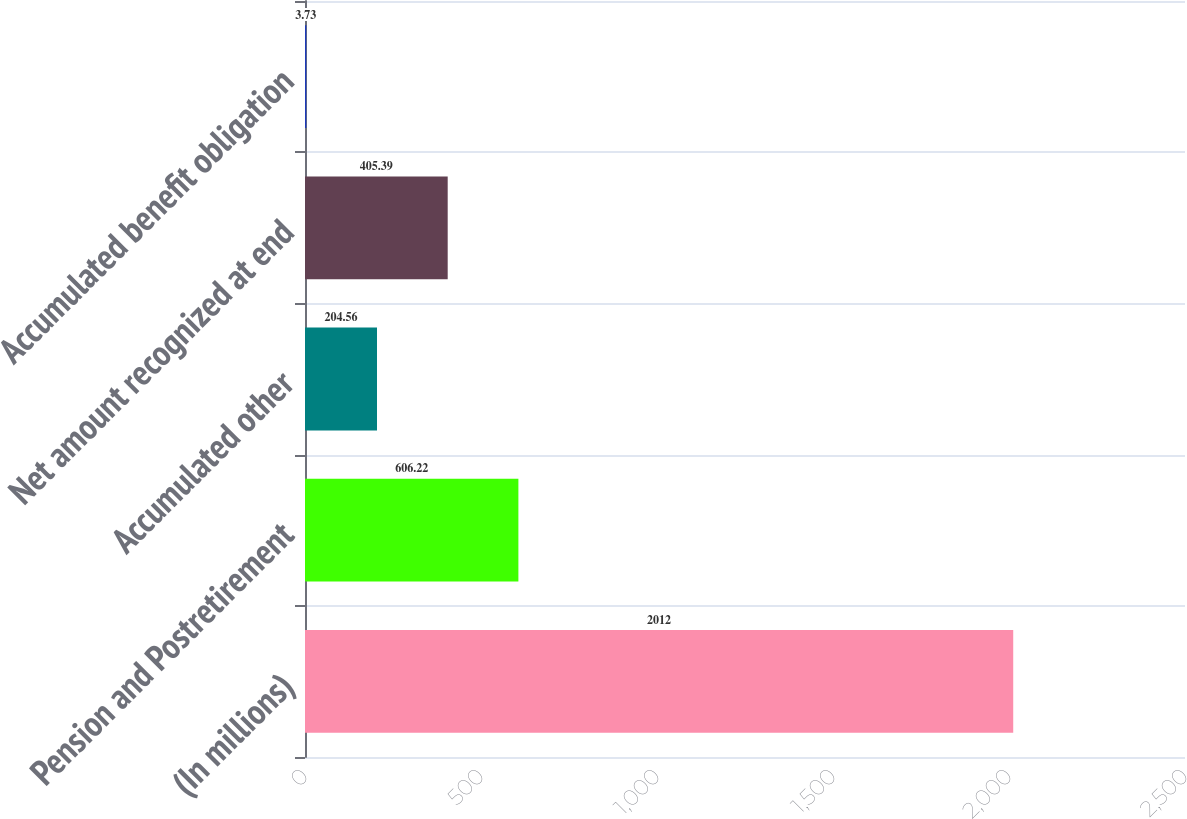Convert chart. <chart><loc_0><loc_0><loc_500><loc_500><bar_chart><fcel>(In millions)<fcel>Pension and Postretirement<fcel>Accumulated other<fcel>Net amount recognized at end<fcel>Accumulated benefit obligation<nl><fcel>2012<fcel>606.22<fcel>204.56<fcel>405.39<fcel>3.73<nl></chart> 